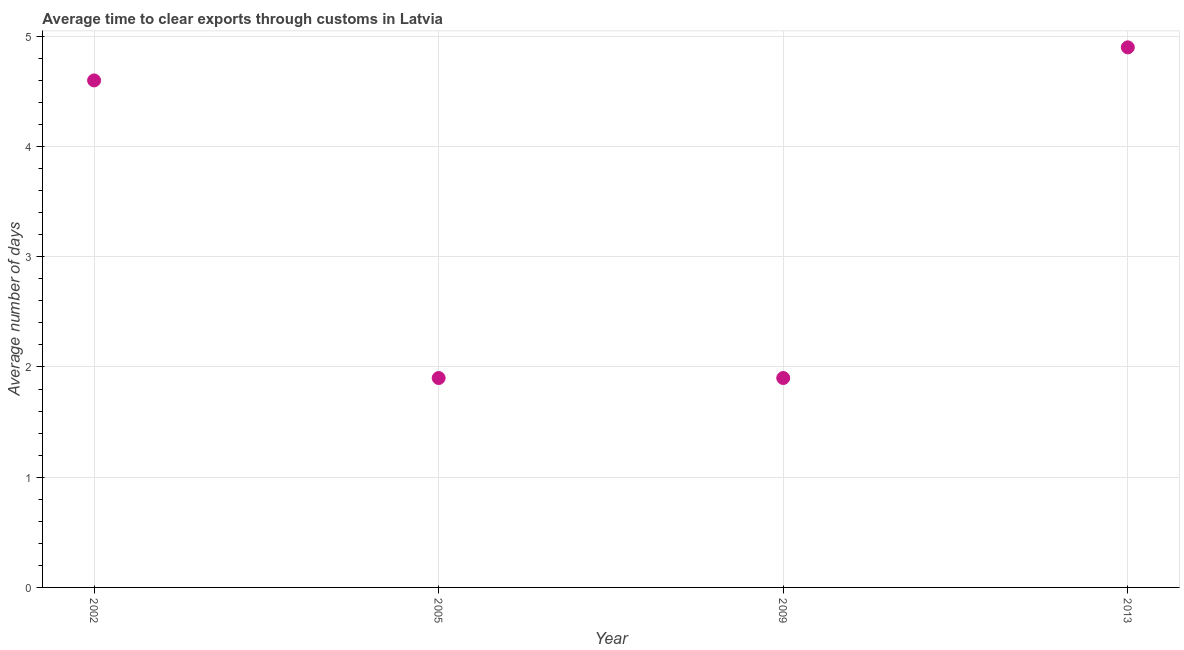Across all years, what is the minimum time to clear exports through customs?
Keep it short and to the point. 1.9. What is the difference between the time to clear exports through customs in 2002 and 2013?
Your answer should be very brief. -0.3. What is the average time to clear exports through customs per year?
Give a very brief answer. 3.33. In how many years, is the time to clear exports through customs greater than 3.4 days?
Your answer should be compact. 2. Do a majority of the years between 2009 and 2002 (inclusive) have time to clear exports through customs greater than 1.2 days?
Your response must be concise. No. What is the ratio of the time to clear exports through customs in 2002 to that in 2009?
Make the answer very short. 2.42. Is the time to clear exports through customs in 2005 less than that in 2009?
Make the answer very short. No. Is the difference between the time to clear exports through customs in 2002 and 2013 greater than the difference between any two years?
Provide a short and direct response. No. What is the difference between the highest and the second highest time to clear exports through customs?
Offer a very short reply. 0.3. Is the sum of the time to clear exports through customs in 2002 and 2005 greater than the maximum time to clear exports through customs across all years?
Keep it short and to the point. Yes. What is the difference between the highest and the lowest time to clear exports through customs?
Ensure brevity in your answer.  3. In how many years, is the time to clear exports through customs greater than the average time to clear exports through customs taken over all years?
Offer a terse response. 2. Does the time to clear exports through customs monotonically increase over the years?
Offer a very short reply. No. How many dotlines are there?
Keep it short and to the point. 1. How many years are there in the graph?
Offer a terse response. 4. Are the values on the major ticks of Y-axis written in scientific E-notation?
Your response must be concise. No. Does the graph contain any zero values?
Your answer should be compact. No. What is the title of the graph?
Provide a short and direct response. Average time to clear exports through customs in Latvia. What is the label or title of the Y-axis?
Ensure brevity in your answer.  Average number of days. What is the Average number of days in 2002?
Keep it short and to the point. 4.6. What is the Average number of days in 2005?
Your answer should be very brief. 1.9. What is the difference between the Average number of days in 2009 and 2013?
Your answer should be compact. -3. What is the ratio of the Average number of days in 2002 to that in 2005?
Your answer should be compact. 2.42. What is the ratio of the Average number of days in 2002 to that in 2009?
Your response must be concise. 2.42. What is the ratio of the Average number of days in 2002 to that in 2013?
Provide a succinct answer. 0.94. What is the ratio of the Average number of days in 2005 to that in 2013?
Your answer should be very brief. 0.39. What is the ratio of the Average number of days in 2009 to that in 2013?
Your response must be concise. 0.39. 